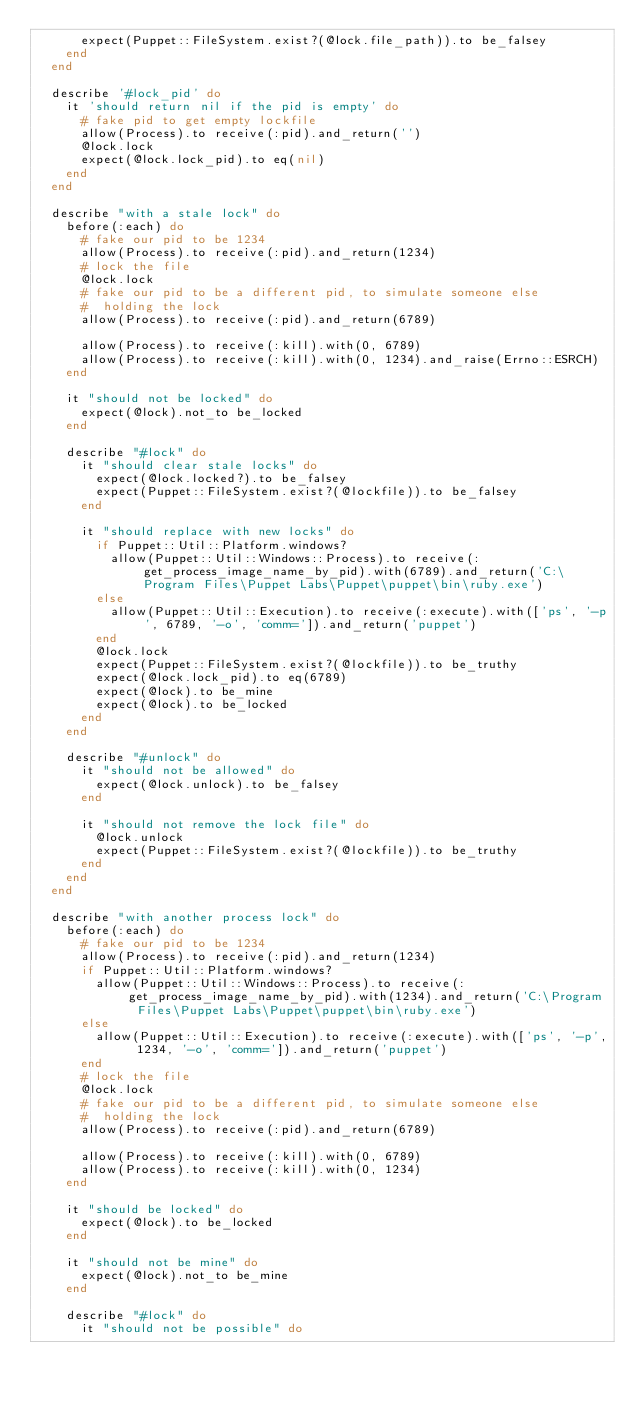Convert code to text. <code><loc_0><loc_0><loc_500><loc_500><_Ruby_>      expect(Puppet::FileSystem.exist?(@lock.file_path)).to be_falsey
    end
  end

  describe '#lock_pid' do
    it 'should return nil if the pid is empty' do
      # fake pid to get empty lockfile
      allow(Process).to receive(:pid).and_return('')
      @lock.lock
      expect(@lock.lock_pid).to eq(nil)
    end
  end

  describe "with a stale lock" do
    before(:each) do
      # fake our pid to be 1234
      allow(Process).to receive(:pid).and_return(1234)
      # lock the file
      @lock.lock
      # fake our pid to be a different pid, to simulate someone else
      #  holding the lock
      allow(Process).to receive(:pid).and_return(6789)

      allow(Process).to receive(:kill).with(0, 6789)
      allow(Process).to receive(:kill).with(0, 1234).and_raise(Errno::ESRCH)
    end

    it "should not be locked" do
      expect(@lock).not_to be_locked
    end

    describe "#lock" do
      it "should clear stale locks" do
        expect(@lock.locked?).to be_falsey
        expect(Puppet::FileSystem.exist?(@lockfile)).to be_falsey
      end

      it "should replace with new locks" do
        if Puppet::Util::Platform.windows?
          allow(Puppet::Util::Windows::Process).to receive(:get_process_image_name_by_pid).with(6789).and_return('C:\Program Files\Puppet Labs\Puppet\puppet\bin\ruby.exe')
        else
          allow(Puppet::Util::Execution).to receive(:execute).with(['ps', '-p', 6789, '-o', 'comm=']).and_return('puppet')
        end
        @lock.lock
        expect(Puppet::FileSystem.exist?(@lockfile)).to be_truthy
        expect(@lock.lock_pid).to eq(6789)
        expect(@lock).to be_mine
        expect(@lock).to be_locked
      end
    end

    describe "#unlock" do
      it "should not be allowed" do
        expect(@lock.unlock).to be_falsey
      end

      it "should not remove the lock file" do
        @lock.unlock
        expect(Puppet::FileSystem.exist?(@lockfile)).to be_truthy
      end
    end
  end

  describe "with another process lock" do
    before(:each) do
      # fake our pid to be 1234
      allow(Process).to receive(:pid).and_return(1234)
      if Puppet::Util::Platform.windows?
        allow(Puppet::Util::Windows::Process).to receive(:get_process_image_name_by_pid).with(1234).and_return('C:\Program Files\Puppet Labs\Puppet\puppet\bin\ruby.exe')
      else
        allow(Puppet::Util::Execution).to receive(:execute).with(['ps', '-p', 1234, '-o', 'comm=']).and_return('puppet')
      end
      # lock the file
      @lock.lock
      # fake our pid to be a different pid, to simulate someone else
      #  holding the lock
      allow(Process).to receive(:pid).and_return(6789)

      allow(Process).to receive(:kill).with(0, 6789)
      allow(Process).to receive(:kill).with(0, 1234)
    end

    it "should be locked" do
      expect(@lock).to be_locked
    end

    it "should not be mine" do
      expect(@lock).not_to be_mine
    end

    describe "#lock" do
      it "should not be possible" do</code> 